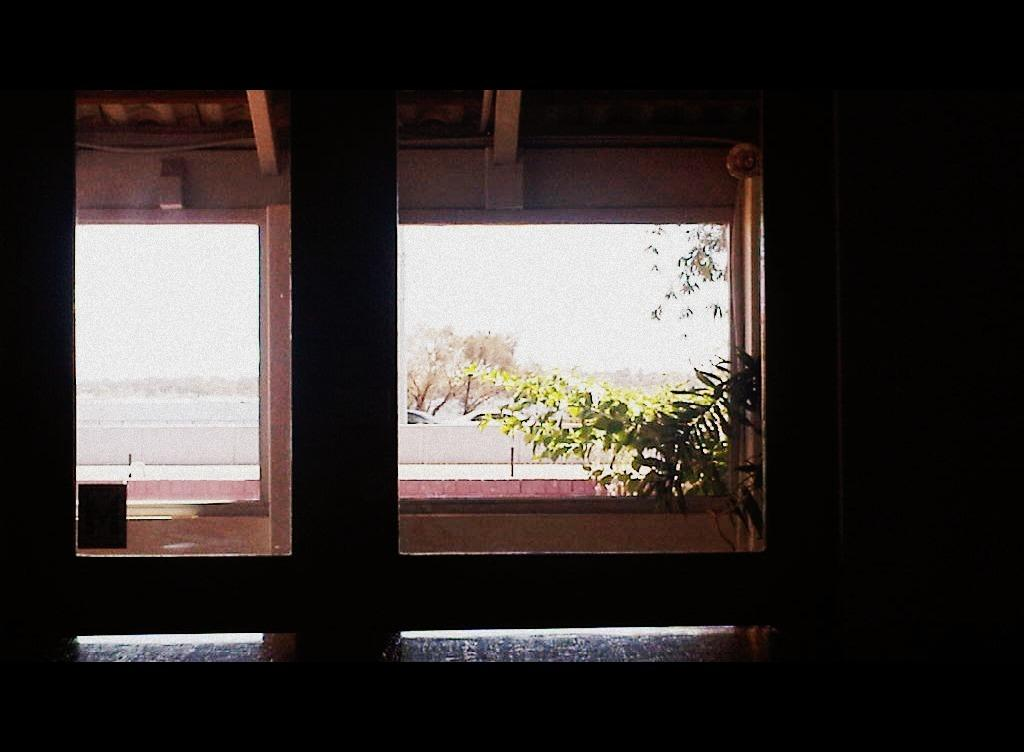Where was the image taken? The image is taken indoors. What can be seen on the wall in the image? There is a wall with a window in the image. What is visible through the window? Trees and the sky are visible through the window. What type of plant is causing trouble in the image? There is no plant present in the image, and therefore no trouble can be attributed to a plant. 